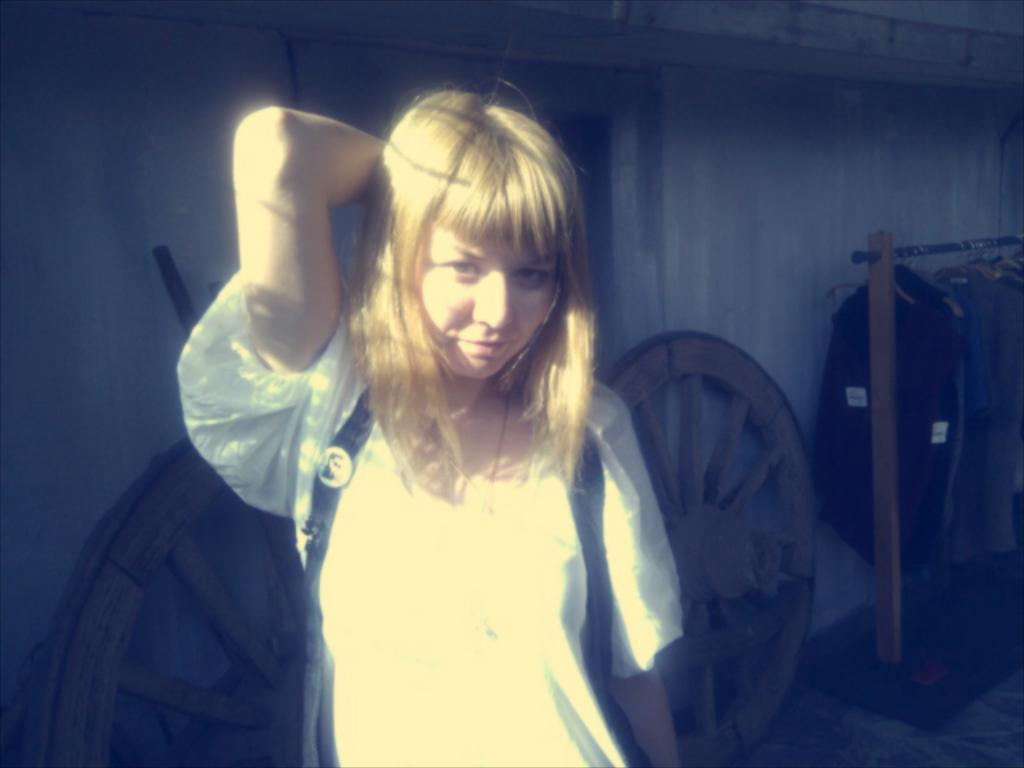Who is present in the image? There is a lady in the image. What can be seen in the background of the image? There are wheels and a wall in the background of the image. What is the lady standing next to? There is a stand in the image, and the lady is standing next to it. What is on the stand? Dresses are hanged on hangers on the stand. What type of mask is the lady's son wearing in the image? There is no mention of a son or a mask in the image; the lady is the only person present. 